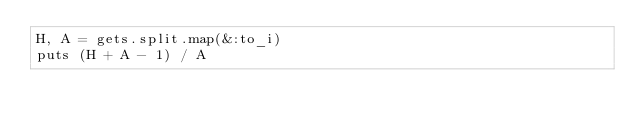<code> <loc_0><loc_0><loc_500><loc_500><_Ruby_>H, A = gets.split.map(&:to_i)
puts (H + A - 1) / A</code> 